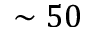Convert formula to latex. <formula><loc_0><loc_0><loc_500><loc_500>\sim 5 0</formula> 